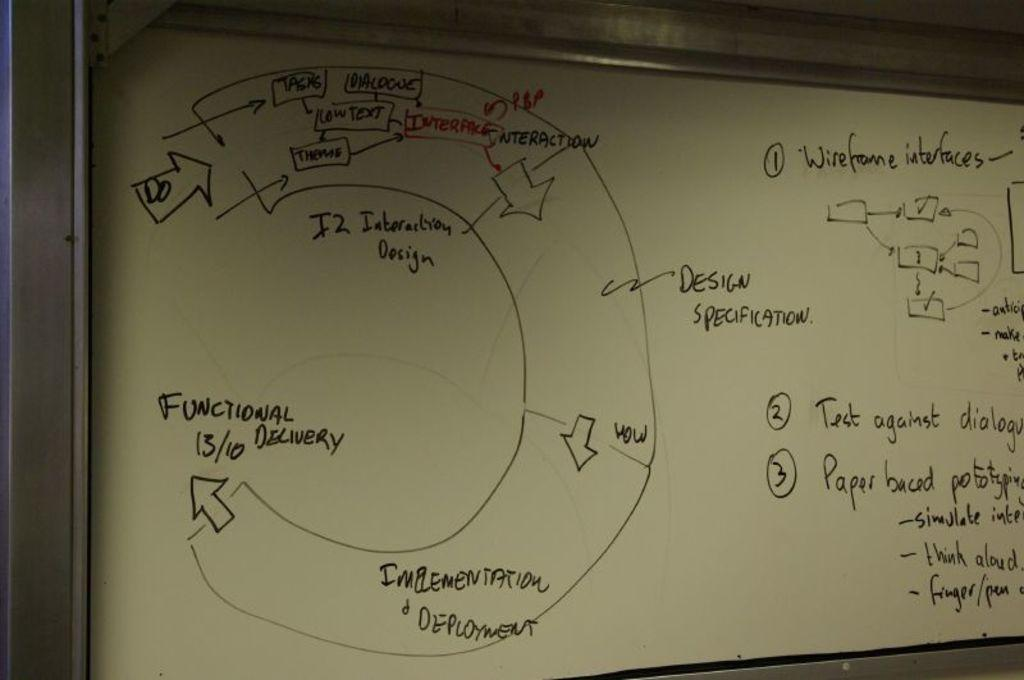Provide a one-sentence caption for the provided image. The whiteboard has a flowcart with functional delivery as the endpoint. 